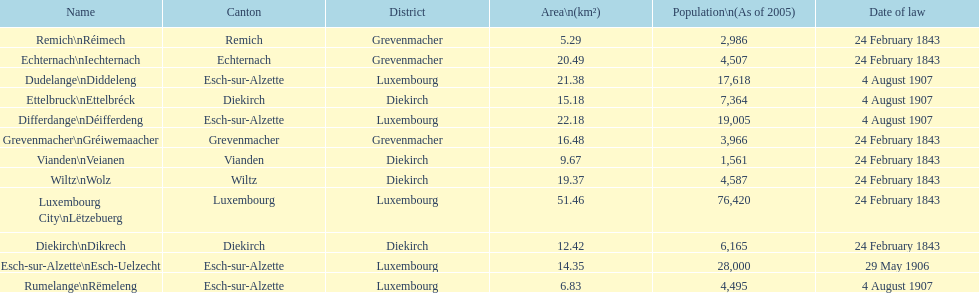How many luxembourg cities had a date of law of feb 24, 1843? 7. 